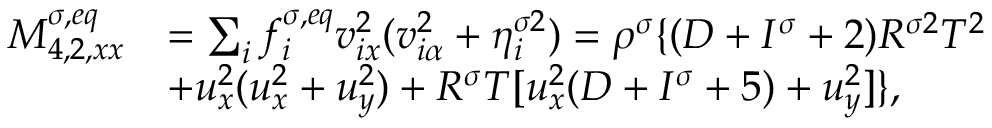Convert formula to latex. <formula><loc_0><loc_0><loc_500><loc_500>\begin{array} { r } { \begin{array} { r l } { M _ { 4 , 2 , x x } ^ { \sigma , e q } } & { = \sum _ { i } f _ { i } ^ { \sigma , e q } v _ { i x } ^ { 2 } ( v _ { i \alpha } ^ { 2 } + \eta _ { i } ^ { \sigma 2 } ) = \rho ^ { \sigma } \{ ( D + I ^ { \sigma } + 2 ) R ^ { \sigma 2 } T ^ { 2 } } \\ & { + u _ { x } ^ { 2 } ( u _ { x } ^ { 2 } + u _ { y } ^ { 2 } ) + R ^ { \sigma } T [ u _ { x } ^ { 2 } ( D + I ^ { \sigma } + 5 ) + u _ { y } ^ { 2 } ] \} , } \end{array} } \end{array}</formula> 